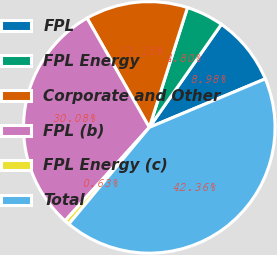Convert chart. <chart><loc_0><loc_0><loc_500><loc_500><pie_chart><fcel>FPL<fcel>FPL Energy<fcel>Corporate and Other<fcel>FPL (b)<fcel>FPL Energy (c)<fcel>Total<nl><fcel>8.98%<fcel>4.8%<fcel>13.15%<fcel>30.08%<fcel>0.63%<fcel>42.36%<nl></chart> 